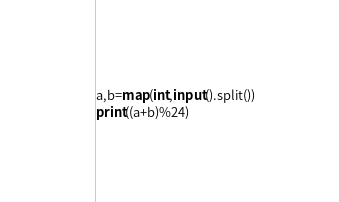<code> <loc_0><loc_0><loc_500><loc_500><_Python_>a,b=map(int,input().split())
print((a+b)%24)
</code> 